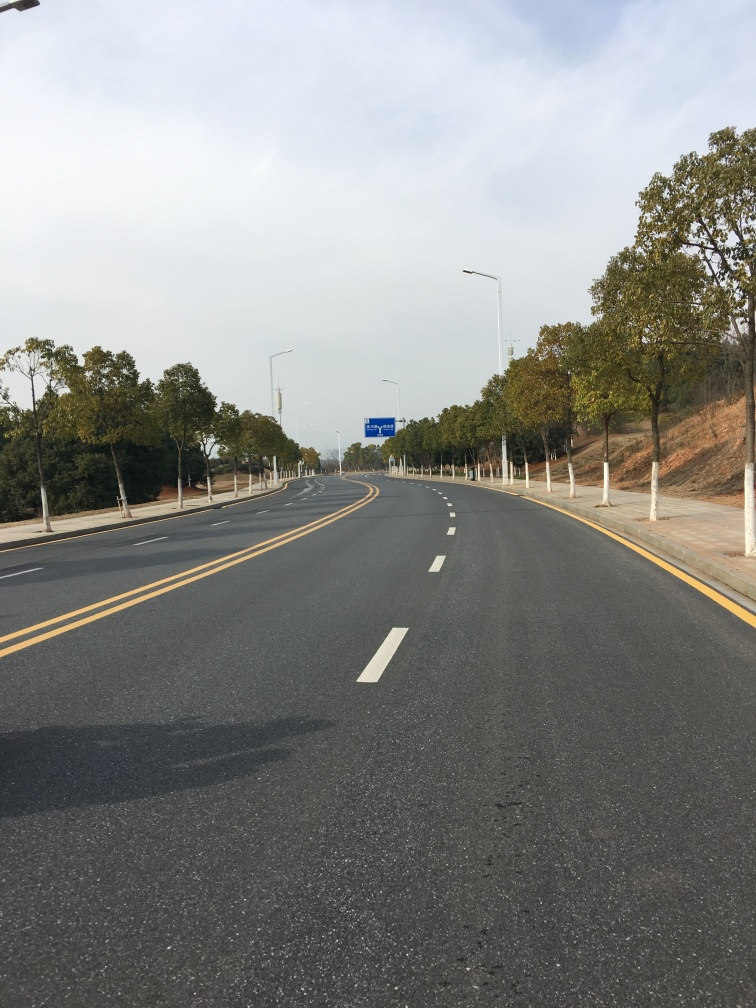Is there any indication of the weather in this image? Yes, the weather appears to be clear as there are very few clouds in the sky. The sunlight bathes the scene, indicating it is likely a dry and pleasant day. 